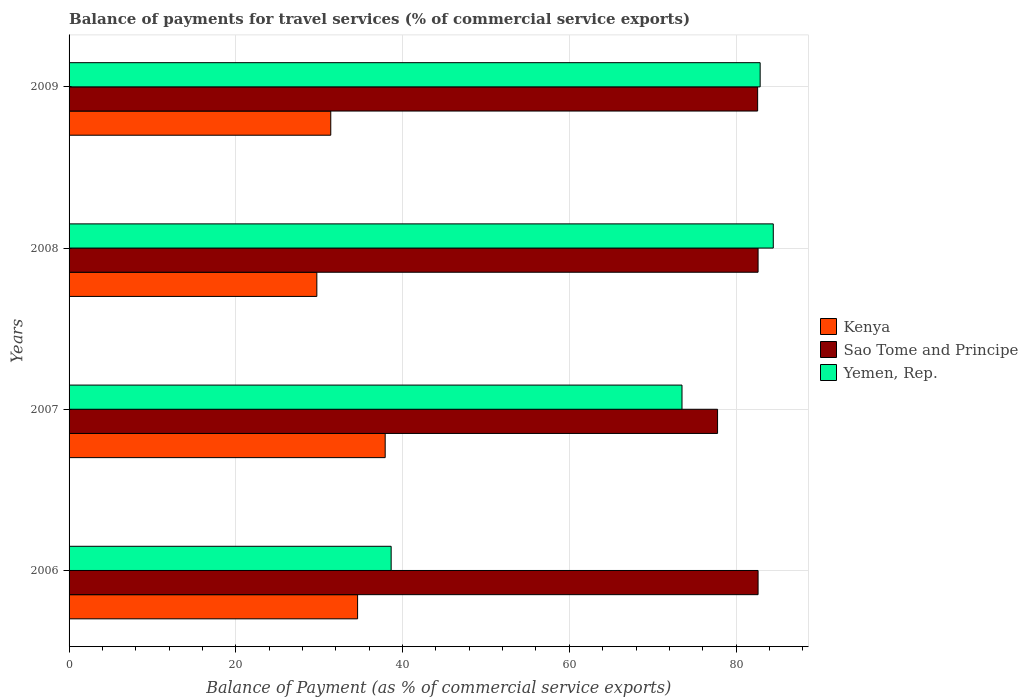How many different coloured bars are there?
Your answer should be very brief. 3. Are the number of bars per tick equal to the number of legend labels?
Keep it short and to the point. Yes. Are the number of bars on each tick of the Y-axis equal?
Ensure brevity in your answer.  Yes. In how many cases, is the number of bars for a given year not equal to the number of legend labels?
Make the answer very short. 0. What is the balance of payments for travel services in Yemen, Rep. in 2007?
Your answer should be very brief. 73.52. Across all years, what is the maximum balance of payments for travel services in Sao Tome and Principe?
Ensure brevity in your answer.  82.64. Across all years, what is the minimum balance of payments for travel services in Sao Tome and Principe?
Your answer should be very brief. 77.78. What is the total balance of payments for travel services in Kenya in the graph?
Keep it short and to the point. 133.63. What is the difference between the balance of payments for travel services in Kenya in 2006 and that in 2008?
Make the answer very short. 4.89. What is the difference between the balance of payments for travel services in Sao Tome and Principe in 2006 and the balance of payments for travel services in Yemen, Rep. in 2008?
Keep it short and to the point. -1.82. What is the average balance of payments for travel services in Sao Tome and Principe per year?
Keep it short and to the point. 81.41. In the year 2009, what is the difference between the balance of payments for travel services in Sao Tome and Principe and balance of payments for travel services in Yemen, Rep.?
Give a very brief answer. -0.3. In how many years, is the balance of payments for travel services in Kenya greater than 72 %?
Give a very brief answer. 0. What is the ratio of the balance of payments for travel services in Kenya in 2006 to that in 2007?
Provide a succinct answer. 0.91. Is the balance of payments for travel services in Yemen, Rep. in 2008 less than that in 2009?
Offer a terse response. No. Is the difference between the balance of payments for travel services in Sao Tome and Principe in 2006 and 2009 greater than the difference between the balance of payments for travel services in Yemen, Rep. in 2006 and 2009?
Your response must be concise. Yes. What is the difference between the highest and the second highest balance of payments for travel services in Yemen, Rep.?
Give a very brief answer. 1.57. What is the difference between the highest and the lowest balance of payments for travel services in Yemen, Rep.?
Ensure brevity in your answer.  45.83. In how many years, is the balance of payments for travel services in Sao Tome and Principe greater than the average balance of payments for travel services in Sao Tome and Principe taken over all years?
Your response must be concise. 3. Is the sum of the balance of payments for travel services in Sao Tome and Principe in 2006 and 2009 greater than the maximum balance of payments for travel services in Kenya across all years?
Provide a succinct answer. Yes. What does the 2nd bar from the top in 2007 represents?
Make the answer very short. Sao Tome and Principe. What does the 2nd bar from the bottom in 2006 represents?
Offer a terse response. Sao Tome and Principe. How many bars are there?
Your response must be concise. 12. Are all the bars in the graph horizontal?
Give a very brief answer. Yes. Does the graph contain grids?
Offer a terse response. Yes. How many legend labels are there?
Your answer should be very brief. 3. How are the legend labels stacked?
Provide a short and direct response. Vertical. What is the title of the graph?
Provide a succinct answer. Balance of payments for travel services (% of commercial service exports). What is the label or title of the X-axis?
Provide a succinct answer. Balance of Payment (as % of commercial service exports). What is the label or title of the Y-axis?
Provide a short and direct response. Years. What is the Balance of Payment (as % of commercial service exports) in Kenya in 2006?
Provide a short and direct response. 34.61. What is the Balance of Payment (as % of commercial service exports) in Sao Tome and Principe in 2006?
Your response must be concise. 82.64. What is the Balance of Payment (as % of commercial service exports) in Yemen, Rep. in 2006?
Your response must be concise. 38.63. What is the Balance of Payment (as % of commercial service exports) of Kenya in 2007?
Provide a succinct answer. 37.92. What is the Balance of Payment (as % of commercial service exports) of Sao Tome and Principe in 2007?
Keep it short and to the point. 77.78. What is the Balance of Payment (as % of commercial service exports) of Yemen, Rep. in 2007?
Provide a succinct answer. 73.52. What is the Balance of Payment (as % of commercial service exports) of Kenya in 2008?
Keep it short and to the point. 29.72. What is the Balance of Payment (as % of commercial service exports) in Sao Tome and Principe in 2008?
Keep it short and to the point. 82.64. What is the Balance of Payment (as % of commercial service exports) in Yemen, Rep. in 2008?
Your response must be concise. 84.47. What is the Balance of Payment (as % of commercial service exports) in Kenya in 2009?
Your answer should be compact. 31.39. What is the Balance of Payment (as % of commercial service exports) of Sao Tome and Principe in 2009?
Your response must be concise. 82.59. What is the Balance of Payment (as % of commercial service exports) in Yemen, Rep. in 2009?
Offer a very short reply. 82.89. Across all years, what is the maximum Balance of Payment (as % of commercial service exports) in Kenya?
Offer a very short reply. 37.92. Across all years, what is the maximum Balance of Payment (as % of commercial service exports) in Sao Tome and Principe?
Give a very brief answer. 82.64. Across all years, what is the maximum Balance of Payment (as % of commercial service exports) in Yemen, Rep.?
Give a very brief answer. 84.47. Across all years, what is the minimum Balance of Payment (as % of commercial service exports) in Kenya?
Offer a very short reply. 29.72. Across all years, what is the minimum Balance of Payment (as % of commercial service exports) in Sao Tome and Principe?
Offer a very short reply. 77.78. Across all years, what is the minimum Balance of Payment (as % of commercial service exports) of Yemen, Rep.?
Ensure brevity in your answer.  38.63. What is the total Balance of Payment (as % of commercial service exports) of Kenya in the graph?
Make the answer very short. 133.63. What is the total Balance of Payment (as % of commercial service exports) in Sao Tome and Principe in the graph?
Ensure brevity in your answer.  325.66. What is the total Balance of Payment (as % of commercial service exports) in Yemen, Rep. in the graph?
Keep it short and to the point. 279.51. What is the difference between the Balance of Payment (as % of commercial service exports) in Kenya in 2006 and that in 2007?
Give a very brief answer. -3.31. What is the difference between the Balance of Payment (as % of commercial service exports) of Sao Tome and Principe in 2006 and that in 2007?
Keep it short and to the point. 4.86. What is the difference between the Balance of Payment (as % of commercial service exports) of Yemen, Rep. in 2006 and that in 2007?
Provide a succinct answer. -34.89. What is the difference between the Balance of Payment (as % of commercial service exports) in Kenya in 2006 and that in 2008?
Offer a very short reply. 4.89. What is the difference between the Balance of Payment (as % of commercial service exports) of Sao Tome and Principe in 2006 and that in 2008?
Make the answer very short. 0. What is the difference between the Balance of Payment (as % of commercial service exports) in Yemen, Rep. in 2006 and that in 2008?
Your answer should be very brief. -45.83. What is the difference between the Balance of Payment (as % of commercial service exports) of Kenya in 2006 and that in 2009?
Your response must be concise. 3.22. What is the difference between the Balance of Payment (as % of commercial service exports) in Sao Tome and Principe in 2006 and that in 2009?
Give a very brief answer. 0.05. What is the difference between the Balance of Payment (as % of commercial service exports) in Yemen, Rep. in 2006 and that in 2009?
Offer a terse response. -44.26. What is the difference between the Balance of Payment (as % of commercial service exports) of Kenya in 2007 and that in 2008?
Make the answer very short. 8.2. What is the difference between the Balance of Payment (as % of commercial service exports) in Sao Tome and Principe in 2007 and that in 2008?
Your answer should be compact. -4.86. What is the difference between the Balance of Payment (as % of commercial service exports) of Yemen, Rep. in 2007 and that in 2008?
Give a very brief answer. -10.95. What is the difference between the Balance of Payment (as % of commercial service exports) of Kenya in 2007 and that in 2009?
Your answer should be compact. 6.53. What is the difference between the Balance of Payment (as % of commercial service exports) in Sao Tome and Principe in 2007 and that in 2009?
Offer a terse response. -4.81. What is the difference between the Balance of Payment (as % of commercial service exports) in Yemen, Rep. in 2007 and that in 2009?
Give a very brief answer. -9.37. What is the difference between the Balance of Payment (as % of commercial service exports) of Kenya in 2008 and that in 2009?
Your answer should be very brief. -1.67. What is the difference between the Balance of Payment (as % of commercial service exports) of Sao Tome and Principe in 2008 and that in 2009?
Provide a short and direct response. 0.05. What is the difference between the Balance of Payment (as % of commercial service exports) of Yemen, Rep. in 2008 and that in 2009?
Your answer should be compact. 1.57. What is the difference between the Balance of Payment (as % of commercial service exports) of Kenya in 2006 and the Balance of Payment (as % of commercial service exports) of Sao Tome and Principe in 2007?
Provide a succinct answer. -43.18. What is the difference between the Balance of Payment (as % of commercial service exports) in Kenya in 2006 and the Balance of Payment (as % of commercial service exports) in Yemen, Rep. in 2007?
Give a very brief answer. -38.91. What is the difference between the Balance of Payment (as % of commercial service exports) of Sao Tome and Principe in 2006 and the Balance of Payment (as % of commercial service exports) of Yemen, Rep. in 2007?
Offer a very short reply. 9.12. What is the difference between the Balance of Payment (as % of commercial service exports) of Kenya in 2006 and the Balance of Payment (as % of commercial service exports) of Sao Tome and Principe in 2008?
Offer a terse response. -48.04. What is the difference between the Balance of Payment (as % of commercial service exports) of Kenya in 2006 and the Balance of Payment (as % of commercial service exports) of Yemen, Rep. in 2008?
Offer a terse response. -49.86. What is the difference between the Balance of Payment (as % of commercial service exports) of Sao Tome and Principe in 2006 and the Balance of Payment (as % of commercial service exports) of Yemen, Rep. in 2008?
Provide a succinct answer. -1.82. What is the difference between the Balance of Payment (as % of commercial service exports) of Kenya in 2006 and the Balance of Payment (as % of commercial service exports) of Sao Tome and Principe in 2009?
Keep it short and to the point. -47.98. What is the difference between the Balance of Payment (as % of commercial service exports) in Kenya in 2006 and the Balance of Payment (as % of commercial service exports) in Yemen, Rep. in 2009?
Offer a terse response. -48.28. What is the difference between the Balance of Payment (as % of commercial service exports) in Sao Tome and Principe in 2006 and the Balance of Payment (as % of commercial service exports) in Yemen, Rep. in 2009?
Provide a succinct answer. -0.25. What is the difference between the Balance of Payment (as % of commercial service exports) of Kenya in 2007 and the Balance of Payment (as % of commercial service exports) of Sao Tome and Principe in 2008?
Provide a short and direct response. -44.73. What is the difference between the Balance of Payment (as % of commercial service exports) of Kenya in 2007 and the Balance of Payment (as % of commercial service exports) of Yemen, Rep. in 2008?
Your answer should be very brief. -46.55. What is the difference between the Balance of Payment (as % of commercial service exports) in Sao Tome and Principe in 2007 and the Balance of Payment (as % of commercial service exports) in Yemen, Rep. in 2008?
Keep it short and to the point. -6.68. What is the difference between the Balance of Payment (as % of commercial service exports) in Kenya in 2007 and the Balance of Payment (as % of commercial service exports) in Sao Tome and Principe in 2009?
Offer a very short reply. -44.67. What is the difference between the Balance of Payment (as % of commercial service exports) in Kenya in 2007 and the Balance of Payment (as % of commercial service exports) in Yemen, Rep. in 2009?
Provide a succinct answer. -44.97. What is the difference between the Balance of Payment (as % of commercial service exports) in Sao Tome and Principe in 2007 and the Balance of Payment (as % of commercial service exports) in Yemen, Rep. in 2009?
Make the answer very short. -5.11. What is the difference between the Balance of Payment (as % of commercial service exports) of Kenya in 2008 and the Balance of Payment (as % of commercial service exports) of Sao Tome and Principe in 2009?
Offer a very short reply. -52.87. What is the difference between the Balance of Payment (as % of commercial service exports) in Kenya in 2008 and the Balance of Payment (as % of commercial service exports) in Yemen, Rep. in 2009?
Offer a terse response. -53.17. What is the difference between the Balance of Payment (as % of commercial service exports) of Sao Tome and Principe in 2008 and the Balance of Payment (as % of commercial service exports) of Yemen, Rep. in 2009?
Provide a short and direct response. -0.25. What is the average Balance of Payment (as % of commercial service exports) in Kenya per year?
Offer a very short reply. 33.41. What is the average Balance of Payment (as % of commercial service exports) of Sao Tome and Principe per year?
Your answer should be very brief. 81.41. What is the average Balance of Payment (as % of commercial service exports) of Yemen, Rep. per year?
Your response must be concise. 69.88. In the year 2006, what is the difference between the Balance of Payment (as % of commercial service exports) of Kenya and Balance of Payment (as % of commercial service exports) of Sao Tome and Principe?
Ensure brevity in your answer.  -48.04. In the year 2006, what is the difference between the Balance of Payment (as % of commercial service exports) in Kenya and Balance of Payment (as % of commercial service exports) in Yemen, Rep.?
Provide a succinct answer. -4.03. In the year 2006, what is the difference between the Balance of Payment (as % of commercial service exports) in Sao Tome and Principe and Balance of Payment (as % of commercial service exports) in Yemen, Rep.?
Keep it short and to the point. 44.01. In the year 2007, what is the difference between the Balance of Payment (as % of commercial service exports) in Kenya and Balance of Payment (as % of commercial service exports) in Sao Tome and Principe?
Make the answer very short. -39.87. In the year 2007, what is the difference between the Balance of Payment (as % of commercial service exports) in Kenya and Balance of Payment (as % of commercial service exports) in Yemen, Rep.?
Give a very brief answer. -35.6. In the year 2007, what is the difference between the Balance of Payment (as % of commercial service exports) of Sao Tome and Principe and Balance of Payment (as % of commercial service exports) of Yemen, Rep.?
Your response must be concise. 4.26. In the year 2008, what is the difference between the Balance of Payment (as % of commercial service exports) in Kenya and Balance of Payment (as % of commercial service exports) in Sao Tome and Principe?
Your response must be concise. -52.92. In the year 2008, what is the difference between the Balance of Payment (as % of commercial service exports) of Kenya and Balance of Payment (as % of commercial service exports) of Yemen, Rep.?
Your response must be concise. -54.75. In the year 2008, what is the difference between the Balance of Payment (as % of commercial service exports) in Sao Tome and Principe and Balance of Payment (as % of commercial service exports) in Yemen, Rep.?
Provide a succinct answer. -1.82. In the year 2009, what is the difference between the Balance of Payment (as % of commercial service exports) of Kenya and Balance of Payment (as % of commercial service exports) of Sao Tome and Principe?
Offer a very short reply. -51.2. In the year 2009, what is the difference between the Balance of Payment (as % of commercial service exports) of Kenya and Balance of Payment (as % of commercial service exports) of Yemen, Rep.?
Offer a terse response. -51.5. In the year 2009, what is the difference between the Balance of Payment (as % of commercial service exports) of Sao Tome and Principe and Balance of Payment (as % of commercial service exports) of Yemen, Rep.?
Give a very brief answer. -0.3. What is the ratio of the Balance of Payment (as % of commercial service exports) in Kenya in 2006 to that in 2007?
Offer a terse response. 0.91. What is the ratio of the Balance of Payment (as % of commercial service exports) in Yemen, Rep. in 2006 to that in 2007?
Keep it short and to the point. 0.53. What is the ratio of the Balance of Payment (as % of commercial service exports) in Kenya in 2006 to that in 2008?
Ensure brevity in your answer.  1.16. What is the ratio of the Balance of Payment (as % of commercial service exports) in Sao Tome and Principe in 2006 to that in 2008?
Provide a short and direct response. 1. What is the ratio of the Balance of Payment (as % of commercial service exports) in Yemen, Rep. in 2006 to that in 2008?
Provide a short and direct response. 0.46. What is the ratio of the Balance of Payment (as % of commercial service exports) of Kenya in 2006 to that in 2009?
Offer a very short reply. 1.1. What is the ratio of the Balance of Payment (as % of commercial service exports) of Yemen, Rep. in 2006 to that in 2009?
Provide a succinct answer. 0.47. What is the ratio of the Balance of Payment (as % of commercial service exports) in Kenya in 2007 to that in 2008?
Your answer should be compact. 1.28. What is the ratio of the Balance of Payment (as % of commercial service exports) of Sao Tome and Principe in 2007 to that in 2008?
Your answer should be compact. 0.94. What is the ratio of the Balance of Payment (as % of commercial service exports) in Yemen, Rep. in 2007 to that in 2008?
Your response must be concise. 0.87. What is the ratio of the Balance of Payment (as % of commercial service exports) of Kenya in 2007 to that in 2009?
Give a very brief answer. 1.21. What is the ratio of the Balance of Payment (as % of commercial service exports) in Sao Tome and Principe in 2007 to that in 2009?
Give a very brief answer. 0.94. What is the ratio of the Balance of Payment (as % of commercial service exports) of Yemen, Rep. in 2007 to that in 2009?
Your response must be concise. 0.89. What is the ratio of the Balance of Payment (as % of commercial service exports) in Kenya in 2008 to that in 2009?
Offer a terse response. 0.95. What is the ratio of the Balance of Payment (as % of commercial service exports) of Yemen, Rep. in 2008 to that in 2009?
Give a very brief answer. 1.02. What is the difference between the highest and the second highest Balance of Payment (as % of commercial service exports) in Kenya?
Keep it short and to the point. 3.31. What is the difference between the highest and the second highest Balance of Payment (as % of commercial service exports) of Yemen, Rep.?
Your response must be concise. 1.57. What is the difference between the highest and the lowest Balance of Payment (as % of commercial service exports) of Kenya?
Provide a short and direct response. 8.2. What is the difference between the highest and the lowest Balance of Payment (as % of commercial service exports) in Sao Tome and Principe?
Offer a terse response. 4.86. What is the difference between the highest and the lowest Balance of Payment (as % of commercial service exports) in Yemen, Rep.?
Your answer should be very brief. 45.83. 